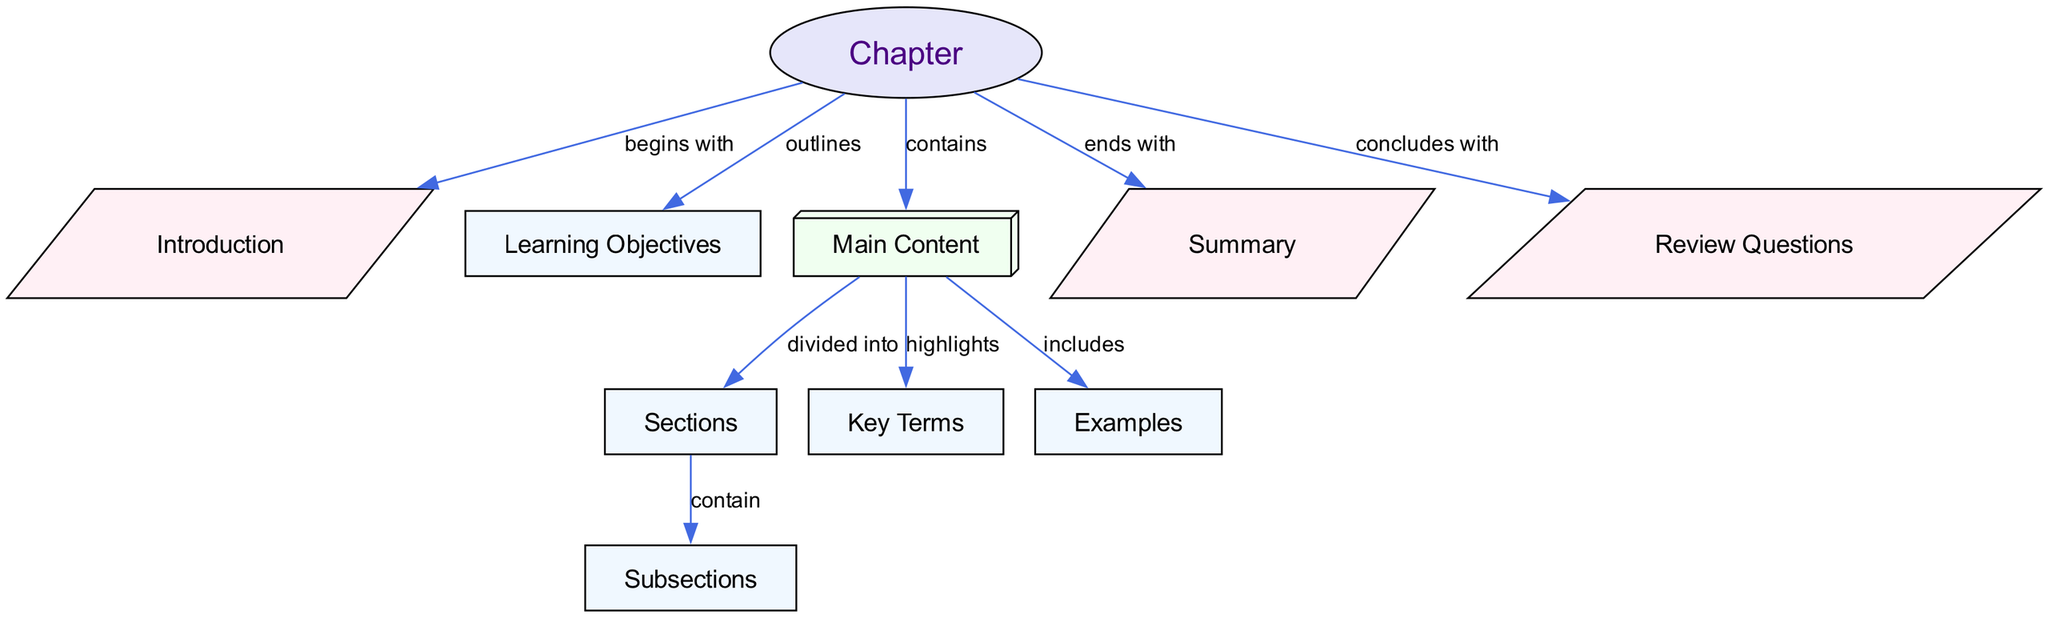What begins a textbook chapter? The diagram shows that the chapter begins with an Introduction, as indicated by the arrow labeled "begins with" leading from "Chapter" to "Introduction".
Answer: Introduction What outlines the learning expectations in a chapter? The diagram specifies that the "Learning Objectives" outline the learning expectations in a chapter, connected by the edge labeled "outlines" from "Chapter" to "Learning Objectives".
Answer: Learning Objectives How many main content elements are highlighted in the chapter? By examining the diagram, under the "Main Content" node, there are three elements highlighted: "Key Terms", "Examples", and the relationship between "Sections" and "Subsections".
Answer: Three What do sections contain within the main content? The diagram shows that "Sections" contain "Subsections", which is connected by an edge labeled "contain". So, sections include subsections.
Answer: Subsections What is the final element of a textbook chapter? According to the diagram, the final element of a textbook chapter is the "Summary", as indicated by the "ends with" connection from "Chapter" to "Summary".
Answer: Summary What concludes a textbook chapter? The diagram states that "Review Questions" conclude a textbook chapter, connected by the edge labeled "concludes with" from "Chapter" to "Review Questions".
Answer: Review Questions Which node is divided into sections? The diagram indicates that the "Main Content" node is divided into "Sections", as shown by the edge labeled "divided into" leading to the "Sections" node.
Answer: Main Content How many types of nodes are present in the diagram? By reviewing the nodes, there are different types represented, including "Chapter", "Introduction", "Main Content", "Sections", "Subsections", "Key Terms", "Examples", "Summary", and "Review Questions", totaling nine distinct types.
Answer: Nine What highlights important concepts in the main content? The diagram shows that "Key Terms" highlight important concepts within the "Main Content", depicted with the edge labeled "highlights" connecting these two nodes.
Answer: Key Terms 